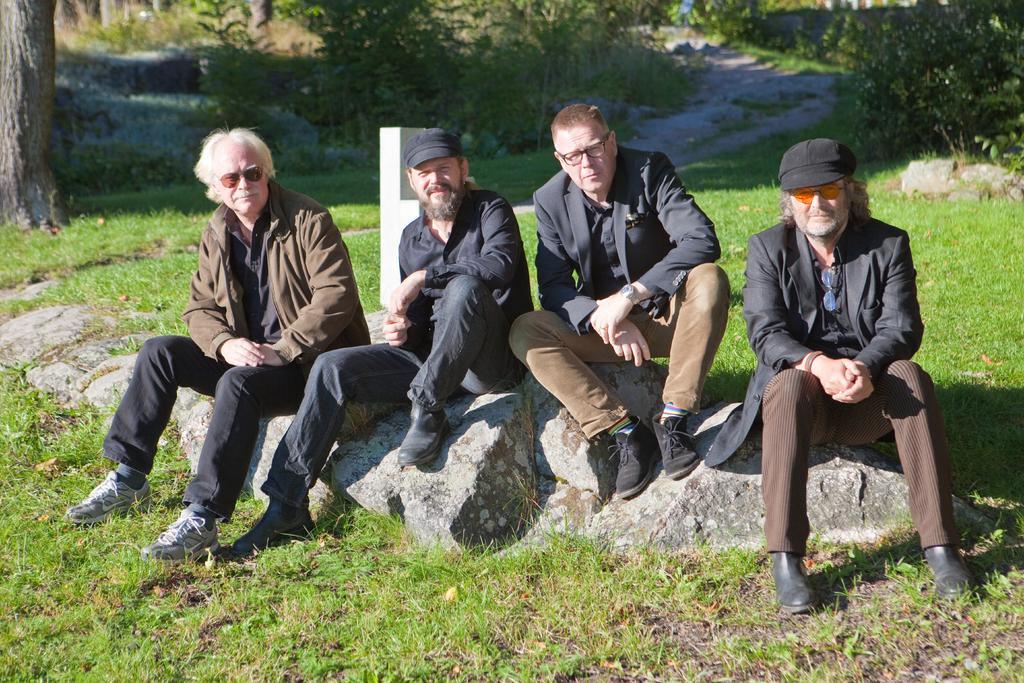Could you give a brief overview of what you see in this image? In this image we can see a group of men sitting on the rock. We can also see a pole, some grass, the bark of a tree, the pathway and a group of plants. 